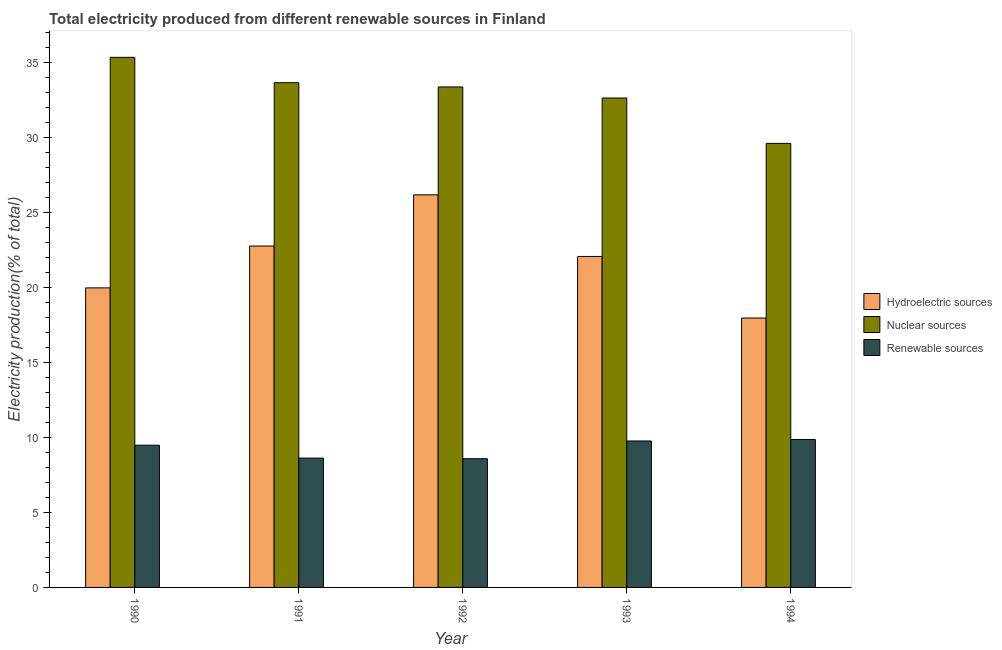How many groups of bars are there?
Offer a very short reply. 5. Are the number of bars on each tick of the X-axis equal?
Ensure brevity in your answer.  Yes. How many bars are there on the 1st tick from the right?
Provide a short and direct response. 3. What is the percentage of electricity produced by hydroelectric sources in 1993?
Keep it short and to the point. 22.06. Across all years, what is the maximum percentage of electricity produced by hydroelectric sources?
Ensure brevity in your answer.  26.17. Across all years, what is the minimum percentage of electricity produced by nuclear sources?
Your answer should be compact. 29.6. In which year was the percentage of electricity produced by hydroelectric sources maximum?
Make the answer very short. 1992. In which year was the percentage of electricity produced by renewable sources minimum?
Give a very brief answer. 1992. What is the total percentage of electricity produced by hydroelectric sources in the graph?
Give a very brief answer. 108.92. What is the difference between the percentage of electricity produced by renewable sources in 1991 and that in 1994?
Offer a terse response. -1.24. What is the difference between the percentage of electricity produced by hydroelectric sources in 1994 and the percentage of electricity produced by renewable sources in 1990?
Keep it short and to the point. -2.01. What is the average percentage of electricity produced by nuclear sources per year?
Provide a succinct answer. 32.92. What is the ratio of the percentage of electricity produced by hydroelectric sources in 1990 to that in 1994?
Give a very brief answer. 1.11. Is the percentage of electricity produced by renewable sources in 1990 less than that in 1994?
Offer a terse response. Yes. Is the difference between the percentage of electricity produced by hydroelectric sources in 1991 and 1993 greater than the difference between the percentage of electricity produced by nuclear sources in 1991 and 1993?
Keep it short and to the point. No. What is the difference between the highest and the second highest percentage of electricity produced by nuclear sources?
Provide a short and direct response. 1.69. What is the difference between the highest and the lowest percentage of electricity produced by hydroelectric sources?
Ensure brevity in your answer.  8.21. In how many years, is the percentage of electricity produced by renewable sources greater than the average percentage of electricity produced by renewable sources taken over all years?
Offer a terse response. 3. What does the 3rd bar from the left in 1994 represents?
Keep it short and to the point. Renewable sources. What does the 3rd bar from the right in 1992 represents?
Your answer should be compact. Hydroelectric sources. Is it the case that in every year, the sum of the percentage of electricity produced by hydroelectric sources and percentage of electricity produced by nuclear sources is greater than the percentage of electricity produced by renewable sources?
Ensure brevity in your answer.  Yes. How many bars are there?
Ensure brevity in your answer.  15. Are all the bars in the graph horizontal?
Your answer should be very brief. No. What is the difference between two consecutive major ticks on the Y-axis?
Offer a very short reply. 5. Does the graph contain grids?
Offer a very short reply. No. Where does the legend appear in the graph?
Ensure brevity in your answer.  Center right. How are the legend labels stacked?
Your answer should be compact. Vertical. What is the title of the graph?
Give a very brief answer. Total electricity produced from different renewable sources in Finland. What is the label or title of the X-axis?
Offer a terse response. Year. What is the Electricity production(% of total) of Hydroelectric sources in 1990?
Your answer should be compact. 19.97. What is the Electricity production(% of total) of Nuclear sources in 1990?
Provide a succinct answer. 35.34. What is the Electricity production(% of total) of Renewable sources in 1990?
Keep it short and to the point. 9.48. What is the Electricity production(% of total) of Hydroelectric sources in 1991?
Ensure brevity in your answer.  22.76. What is the Electricity production(% of total) of Nuclear sources in 1991?
Provide a succinct answer. 33.65. What is the Electricity production(% of total) in Renewable sources in 1991?
Offer a terse response. 8.62. What is the Electricity production(% of total) in Hydroelectric sources in 1992?
Keep it short and to the point. 26.17. What is the Electricity production(% of total) in Nuclear sources in 1992?
Your response must be concise. 33.37. What is the Electricity production(% of total) in Renewable sources in 1992?
Give a very brief answer. 8.58. What is the Electricity production(% of total) in Hydroelectric sources in 1993?
Keep it short and to the point. 22.06. What is the Electricity production(% of total) of Nuclear sources in 1993?
Provide a succinct answer. 32.63. What is the Electricity production(% of total) in Renewable sources in 1993?
Offer a very short reply. 9.76. What is the Electricity production(% of total) in Hydroelectric sources in 1994?
Offer a terse response. 17.96. What is the Electricity production(% of total) in Nuclear sources in 1994?
Offer a terse response. 29.6. What is the Electricity production(% of total) in Renewable sources in 1994?
Provide a succinct answer. 9.86. Across all years, what is the maximum Electricity production(% of total) in Hydroelectric sources?
Offer a very short reply. 26.17. Across all years, what is the maximum Electricity production(% of total) of Nuclear sources?
Your response must be concise. 35.34. Across all years, what is the maximum Electricity production(% of total) of Renewable sources?
Ensure brevity in your answer.  9.86. Across all years, what is the minimum Electricity production(% of total) of Hydroelectric sources?
Your response must be concise. 17.96. Across all years, what is the minimum Electricity production(% of total) of Nuclear sources?
Give a very brief answer. 29.6. Across all years, what is the minimum Electricity production(% of total) in Renewable sources?
Offer a very short reply. 8.58. What is the total Electricity production(% of total) in Hydroelectric sources in the graph?
Your response must be concise. 108.92. What is the total Electricity production(% of total) of Nuclear sources in the graph?
Provide a succinct answer. 164.58. What is the total Electricity production(% of total) of Renewable sources in the graph?
Provide a succinct answer. 46.31. What is the difference between the Electricity production(% of total) in Hydroelectric sources in 1990 and that in 1991?
Your answer should be compact. -2.79. What is the difference between the Electricity production(% of total) in Nuclear sources in 1990 and that in 1991?
Provide a succinct answer. 1.69. What is the difference between the Electricity production(% of total) of Renewable sources in 1990 and that in 1991?
Offer a terse response. 0.86. What is the difference between the Electricity production(% of total) in Hydroelectric sources in 1990 and that in 1992?
Offer a very short reply. -6.2. What is the difference between the Electricity production(% of total) of Nuclear sources in 1990 and that in 1992?
Your response must be concise. 1.97. What is the difference between the Electricity production(% of total) in Renewable sources in 1990 and that in 1992?
Ensure brevity in your answer.  0.9. What is the difference between the Electricity production(% of total) of Hydroelectric sources in 1990 and that in 1993?
Provide a short and direct response. -2.09. What is the difference between the Electricity production(% of total) in Nuclear sources in 1990 and that in 1993?
Provide a short and direct response. 2.71. What is the difference between the Electricity production(% of total) of Renewable sources in 1990 and that in 1993?
Make the answer very short. -0.28. What is the difference between the Electricity production(% of total) in Hydroelectric sources in 1990 and that in 1994?
Offer a very short reply. 2.01. What is the difference between the Electricity production(% of total) in Nuclear sources in 1990 and that in 1994?
Your answer should be compact. 5.74. What is the difference between the Electricity production(% of total) in Renewable sources in 1990 and that in 1994?
Your answer should be compact. -0.38. What is the difference between the Electricity production(% of total) of Hydroelectric sources in 1991 and that in 1992?
Provide a succinct answer. -3.41. What is the difference between the Electricity production(% of total) in Nuclear sources in 1991 and that in 1992?
Offer a terse response. 0.28. What is the difference between the Electricity production(% of total) in Renewable sources in 1991 and that in 1992?
Make the answer very short. 0.04. What is the difference between the Electricity production(% of total) of Hydroelectric sources in 1991 and that in 1993?
Give a very brief answer. 0.7. What is the difference between the Electricity production(% of total) of Nuclear sources in 1991 and that in 1993?
Offer a terse response. 1.02. What is the difference between the Electricity production(% of total) of Renewable sources in 1991 and that in 1993?
Your answer should be very brief. -1.14. What is the difference between the Electricity production(% of total) of Hydroelectric sources in 1991 and that in 1994?
Give a very brief answer. 4.8. What is the difference between the Electricity production(% of total) in Nuclear sources in 1991 and that in 1994?
Give a very brief answer. 4.05. What is the difference between the Electricity production(% of total) in Renewable sources in 1991 and that in 1994?
Make the answer very short. -1.24. What is the difference between the Electricity production(% of total) of Hydroelectric sources in 1992 and that in 1993?
Your answer should be very brief. 4.11. What is the difference between the Electricity production(% of total) of Nuclear sources in 1992 and that in 1993?
Your answer should be compact. 0.74. What is the difference between the Electricity production(% of total) in Renewable sources in 1992 and that in 1993?
Offer a terse response. -1.18. What is the difference between the Electricity production(% of total) in Hydroelectric sources in 1992 and that in 1994?
Provide a succinct answer. 8.21. What is the difference between the Electricity production(% of total) in Nuclear sources in 1992 and that in 1994?
Provide a succinct answer. 3.76. What is the difference between the Electricity production(% of total) in Renewable sources in 1992 and that in 1994?
Offer a very short reply. -1.28. What is the difference between the Electricity production(% of total) in Hydroelectric sources in 1993 and that in 1994?
Ensure brevity in your answer.  4.1. What is the difference between the Electricity production(% of total) in Nuclear sources in 1993 and that in 1994?
Make the answer very short. 3.03. What is the difference between the Electricity production(% of total) in Renewable sources in 1993 and that in 1994?
Offer a terse response. -0.1. What is the difference between the Electricity production(% of total) in Hydroelectric sources in 1990 and the Electricity production(% of total) in Nuclear sources in 1991?
Your response must be concise. -13.68. What is the difference between the Electricity production(% of total) in Hydroelectric sources in 1990 and the Electricity production(% of total) in Renewable sources in 1991?
Provide a short and direct response. 11.35. What is the difference between the Electricity production(% of total) of Nuclear sources in 1990 and the Electricity production(% of total) of Renewable sources in 1991?
Your answer should be compact. 26.72. What is the difference between the Electricity production(% of total) of Hydroelectric sources in 1990 and the Electricity production(% of total) of Nuclear sources in 1992?
Keep it short and to the point. -13.4. What is the difference between the Electricity production(% of total) of Hydroelectric sources in 1990 and the Electricity production(% of total) of Renewable sources in 1992?
Give a very brief answer. 11.39. What is the difference between the Electricity production(% of total) in Nuclear sources in 1990 and the Electricity production(% of total) in Renewable sources in 1992?
Your answer should be very brief. 26.76. What is the difference between the Electricity production(% of total) of Hydroelectric sources in 1990 and the Electricity production(% of total) of Nuclear sources in 1993?
Provide a short and direct response. -12.66. What is the difference between the Electricity production(% of total) of Hydroelectric sources in 1990 and the Electricity production(% of total) of Renewable sources in 1993?
Provide a short and direct response. 10.21. What is the difference between the Electricity production(% of total) in Nuclear sources in 1990 and the Electricity production(% of total) in Renewable sources in 1993?
Your answer should be compact. 25.58. What is the difference between the Electricity production(% of total) of Hydroelectric sources in 1990 and the Electricity production(% of total) of Nuclear sources in 1994?
Provide a succinct answer. -9.63. What is the difference between the Electricity production(% of total) in Hydroelectric sources in 1990 and the Electricity production(% of total) in Renewable sources in 1994?
Offer a very short reply. 10.11. What is the difference between the Electricity production(% of total) in Nuclear sources in 1990 and the Electricity production(% of total) in Renewable sources in 1994?
Make the answer very short. 25.48. What is the difference between the Electricity production(% of total) of Hydroelectric sources in 1991 and the Electricity production(% of total) of Nuclear sources in 1992?
Keep it short and to the point. -10.61. What is the difference between the Electricity production(% of total) of Hydroelectric sources in 1991 and the Electricity production(% of total) of Renewable sources in 1992?
Make the answer very short. 14.18. What is the difference between the Electricity production(% of total) in Nuclear sources in 1991 and the Electricity production(% of total) in Renewable sources in 1992?
Provide a succinct answer. 25.07. What is the difference between the Electricity production(% of total) in Hydroelectric sources in 1991 and the Electricity production(% of total) in Nuclear sources in 1993?
Your answer should be very brief. -9.87. What is the difference between the Electricity production(% of total) of Hydroelectric sources in 1991 and the Electricity production(% of total) of Renewable sources in 1993?
Make the answer very short. 13. What is the difference between the Electricity production(% of total) of Nuclear sources in 1991 and the Electricity production(% of total) of Renewable sources in 1993?
Keep it short and to the point. 23.89. What is the difference between the Electricity production(% of total) in Hydroelectric sources in 1991 and the Electricity production(% of total) in Nuclear sources in 1994?
Your answer should be very brief. -6.84. What is the difference between the Electricity production(% of total) in Hydroelectric sources in 1991 and the Electricity production(% of total) in Renewable sources in 1994?
Offer a terse response. 12.9. What is the difference between the Electricity production(% of total) of Nuclear sources in 1991 and the Electricity production(% of total) of Renewable sources in 1994?
Offer a very short reply. 23.79. What is the difference between the Electricity production(% of total) in Hydroelectric sources in 1992 and the Electricity production(% of total) in Nuclear sources in 1993?
Your answer should be very brief. -6.46. What is the difference between the Electricity production(% of total) of Hydroelectric sources in 1992 and the Electricity production(% of total) of Renewable sources in 1993?
Provide a short and direct response. 16.41. What is the difference between the Electricity production(% of total) of Nuclear sources in 1992 and the Electricity production(% of total) of Renewable sources in 1993?
Offer a terse response. 23.6. What is the difference between the Electricity production(% of total) of Hydroelectric sources in 1992 and the Electricity production(% of total) of Nuclear sources in 1994?
Your response must be concise. -3.43. What is the difference between the Electricity production(% of total) in Hydroelectric sources in 1992 and the Electricity production(% of total) in Renewable sources in 1994?
Offer a terse response. 16.31. What is the difference between the Electricity production(% of total) in Nuclear sources in 1992 and the Electricity production(% of total) in Renewable sources in 1994?
Your response must be concise. 23.5. What is the difference between the Electricity production(% of total) in Hydroelectric sources in 1993 and the Electricity production(% of total) in Nuclear sources in 1994?
Your answer should be compact. -7.54. What is the difference between the Electricity production(% of total) of Hydroelectric sources in 1993 and the Electricity production(% of total) of Renewable sources in 1994?
Provide a short and direct response. 12.2. What is the difference between the Electricity production(% of total) in Nuclear sources in 1993 and the Electricity production(% of total) in Renewable sources in 1994?
Offer a very short reply. 22.76. What is the average Electricity production(% of total) in Hydroelectric sources per year?
Your response must be concise. 21.78. What is the average Electricity production(% of total) in Nuclear sources per year?
Provide a succinct answer. 32.92. What is the average Electricity production(% of total) in Renewable sources per year?
Provide a succinct answer. 9.26. In the year 1990, what is the difference between the Electricity production(% of total) in Hydroelectric sources and Electricity production(% of total) in Nuclear sources?
Provide a succinct answer. -15.37. In the year 1990, what is the difference between the Electricity production(% of total) in Hydroelectric sources and Electricity production(% of total) in Renewable sources?
Make the answer very short. 10.49. In the year 1990, what is the difference between the Electricity production(% of total) in Nuclear sources and Electricity production(% of total) in Renewable sources?
Provide a short and direct response. 25.86. In the year 1991, what is the difference between the Electricity production(% of total) in Hydroelectric sources and Electricity production(% of total) in Nuclear sources?
Your response must be concise. -10.89. In the year 1991, what is the difference between the Electricity production(% of total) of Hydroelectric sources and Electricity production(% of total) of Renewable sources?
Keep it short and to the point. 14.14. In the year 1991, what is the difference between the Electricity production(% of total) in Nuclear sources and Electricity production(% of total) in Renewable sources?
Give a very brief answer. 25.02. In the year 1992, what is the difference between the Electricity production(% of total) of Hydroelectric sources and Electricity production(% of total) of Nuclear sources?
Ensure brevity in your answer.  -7.19. In the year 1992, what is the difference between the Electricity production(% of total) in Hydroelectric sources and Electricity production(% of total) in Renewable sources?
Provide a succinct answer. 17.59. In the year 1992, what is the difference between the Electricity production(% of total) of Nuclear sources and Electricity production(% of total) of Renewable sources?
Your response must be concise. 24.78. In the year 1993, what is the difference between the Electricity production(% of total) of Hydroelectric sources and Electricity production(% of total) of Nuclear sources?
Your response must be concise. -10.56. In the year 1993, what is the difference between the Electricity production(% of total) of Hydroelectric sources and Electricity production(% of total) of Renewable sources?
Your answer should be compact. 12.3. In the year 1993, what is the difference between the Electricity production(% of total) of Nuclear sources and Electricity production(% of total) of Renewable sources?
Provide a succinct answer. 22.86. In the year 1994, what is the difference between the Electricity production(% of total) in Hydroelectric sources and Electricity production(% of total) in Nuclear sources?
Ensure brevity in your answer.  -11.64. In the year 1994, what is the difference between the Electricity production(% of total) of Hydroelectric sources and Electricity production(% of total) of Renewable sources?
Offer a very short reply. 8.1. In the year 1994, what is the difference between the Electricity production(% of total) in Nuclear sources and Electricity production(% of total) in Renewable sources?
Provide a succinct answer. 19.74. What is the ratio of the Electricity production(% of total) of Hydroelectric sources in 1990 to that in 1991?
Ensure brevity in your answer.  0.88. What is the ratio of the Electricity production(% of total) of Nuclear sources in 1990 to that in 1991?
Make the answer very short. 1.05. What is the ratio of the Electricity production(% of total) of Renewable sources in 1990 to that in 1991?
Provide a succinct answer. 1.1. What is the ratio of the Electricity production(% of total) in Hydroelectric sources in 1990 to that in 1992?
Make the answer very short. 0.76. What is the ratio of the Electricity production(% of total) in Nuclear sources in 1990 to that in 1992?
Keep it short and to the point. 1.06. What is the ratio of the Electricity production(% of total) of Renewable sources in 1990 to that in 1992?
Your answer should be compact. 1.11. What is the ratio of the Electricity production(% of total) of Hydroelectric sources in 1990 to that in 1993?
Your response must be concise. 0.91. What is the ratio of the Electricity production(% of total) of Nuclear sources in 1990 to that in 1993?
Provide a short and direct response. 1.08. What is the ratio of the Electricity production(% of total) of Renewable sources in 1990 to that in 1993?
Offer a very short reply. 0.97. What is the ratio of the Electricity production(% of total) of Hydroelectric sources in 1990 to that in 1994?
Make the answer very short. 1.11. What is the ratio of the Electricity production(% of total) of Nuclear sources in 1990 to that in 1994?
Ensure brevity in your answer.  1.19. What is the ratio of the Electricity production(% of total) in Renewable sources in 1990 to that in 1994?
Your answer should be compact. 0.96. What is the ratio of the Electricity production(% of total) of Hydroelectric sources in 1991 to that in 1992?
Offer a very short reply. 0.87. What is the ratio of the Electricity production(% of total) in Nuclear sources in 1991 to that in 1992?
Ensure brevity in your answer.  1.01. What is the ratio of the Electricity production(% of total) of Hydroelectric sources in 1991 to that in 1993?
Keep it short and to the point. 1.03. What is the ratio of the Electricity production(% of total) in Nuclear sources in 1991 to that in 1993?
Your answer should be very brief. 1.03. What is the ratio of the Electricity production(% of total) in Renewable sources in 1991 to that in 1993?
Give a very brief answer. 0.88. What is the ratio of the Electricity production(% of total) of Hydroelectric sources in 1991 to that in 1994?
Your answer should be very brief. 1.27. What is the ratio of the Electricity production(% of total) of Nuclear sources in 1991 to that in 1994?
Your answer should be compact. 1.14. What is the ratio of the Electricity production(% of total) in Renewable sources in 1991 to that in 1994?
Provide a succinct answer. 0.87. What is the ratio of the Electricity production(% of total) of Hydroelectric sources in 1992 to that in 1993?
Your answer should be compact. 1.19. What is the ratio of the Electricity production(% of total) of Nuclear sources in 1992 to that in 1993?
Make the answer very short. 1.02. What is the ratio of the Electricity production(% of total) of Renewable sources in 1992 to that in 1993?
Ensure brevity in your answer.  0.88. What is the ratio of the Electricity production(% of total) in Hydroelectric sources in 1992 to that in 1994?
Your answer should be compact. 1.46. What is the ratio of the Electricity production(% of total) in Nuclear sources in 1992 to that in 1994?
Make the answer very short. 1.13. What is the ratio of the Electricity production(% of total) of Renewable sources in 1992 to that in 1994?
Keep it short and to the point. 0.87. What is the ratio of the Electricity production(% of total) in Hydroelectric sources in 1993 to that in 1994?
Offer a terse response. 1.23. What is the ratio of the Electricity production(% of total) in Nuclear sources in 1993 to that in 1994?
Keep it short and to the point. 1.1. What is the difference between the highest and the second highest Electricity production(% of total) of Hydroelectric sources?
Your answer should be compact. 3.41. What is the difference between the highest and the second highest Electricity production(% of total) in Nuclear sources?
Keep it short and to the point. 1.69. What is the difference between the highest and the lowest Electricity production(% of total) in Hydroelectric sources?
Offer a terse response. 8.21. What is the difference between the highest and the lowest Electricity production(% of total) of Nuclear sources?
Give a very brief answer. 5.74. What is the difference between the highest and the lowest Electricity production(% of total) of Renewable sources?
Make the answer very short. 1.28. 